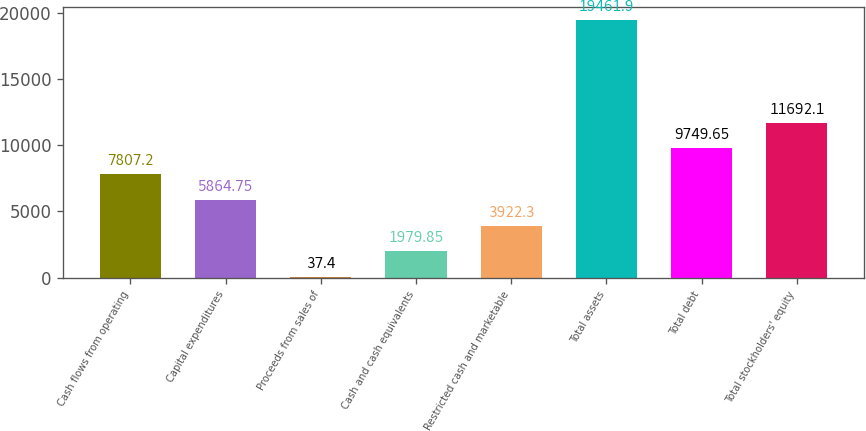<chart> <loc_0><loc_0><loc_500><loc_500><bar_chart><fcel>Cash flows from operating<fcel>Capital expenditures<fcel>Proceeds from sales of<fcel>Cash and cash equivalents<fcel>Restricted cash and marketable<fcel>Total assets<fcel>Total debt<fcel>Total stockholders' equity<nl><fcel>7807.2<fcel>5864.75<fcel>37.4<fcel>1979.85<fcel>3922.3<fcel>19461.9<fcel>9749.65<fcel>11692.1<nl></chart> 